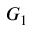<formula> <loc_0><loc_0><loc_500><loc_500>G _ { 1 }</formula> 